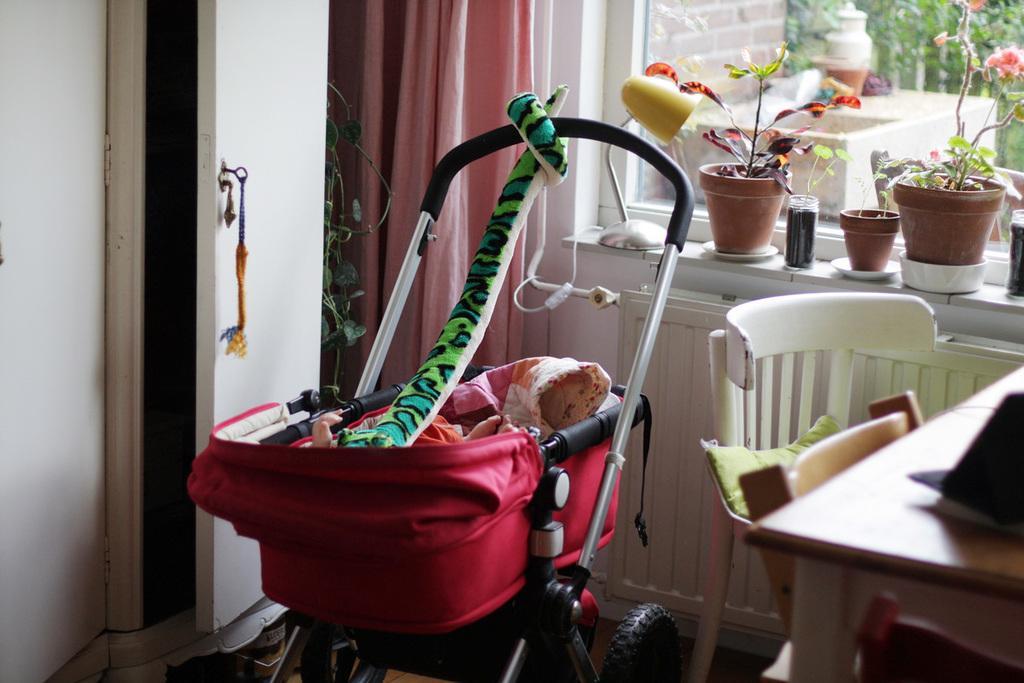Please provide a concise description of this image. In this image we can see a children trolley,table and a chair. At the back side we can see a flower pot,curtain and a cupboard. 